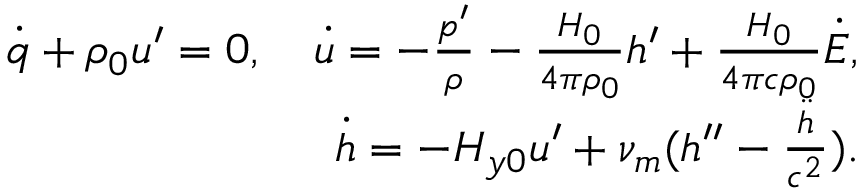<formula> <loc_0><loc_0><loc_500><loc_500>\begin{array} { r } { \dot { q } + \rho _ { 0 } u ^ { \prime } = 0 , \quad \dot { u } = - \frac { p ^ { \prime } } { \rho } - \frac { H _ { 0 } } { 4 \pi \rho _ { 0 } } h ^ { \prime } + \frac { H _ { 0 } } { 4 \pi c \rho _ { 0 } } \dot { E } , } \\ { \dot { h } = - H _ { y 0 } u ^ { \prime } + \nu _ { m } ( h ^ { \prime \prime } - \frac { \ddot { h } } { c ^ { 2 } } ) . } \end{array}</formula> 